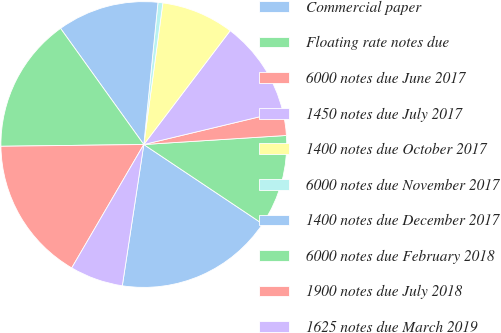Convert chart. <chart><loc_0><loc_0><loc_500><loc_500><pie_chart><fcel>Commercial paper<fcel>Floating rate notes due<fcel>6000 notes due June 2017<fcel>1450 notes due July 2017<fcel>1400 notes due October 2017<fcel>6000 notes due November 2017<fcel>1400 notes due December 2017<fcel>6000 notes due February 2018<fcel>1900 notes due July 2018<fcel>1625 notes due March 2019<nl><fcel>18.03%<fcel>10.38%<fcel>2.73%<fcel>10.93%<fcel>8.2%<fcel>0.55%<fcel>11.48%<fcel>15.3%<fcel>16.39%<fcel>6.01%<nl></chart> 